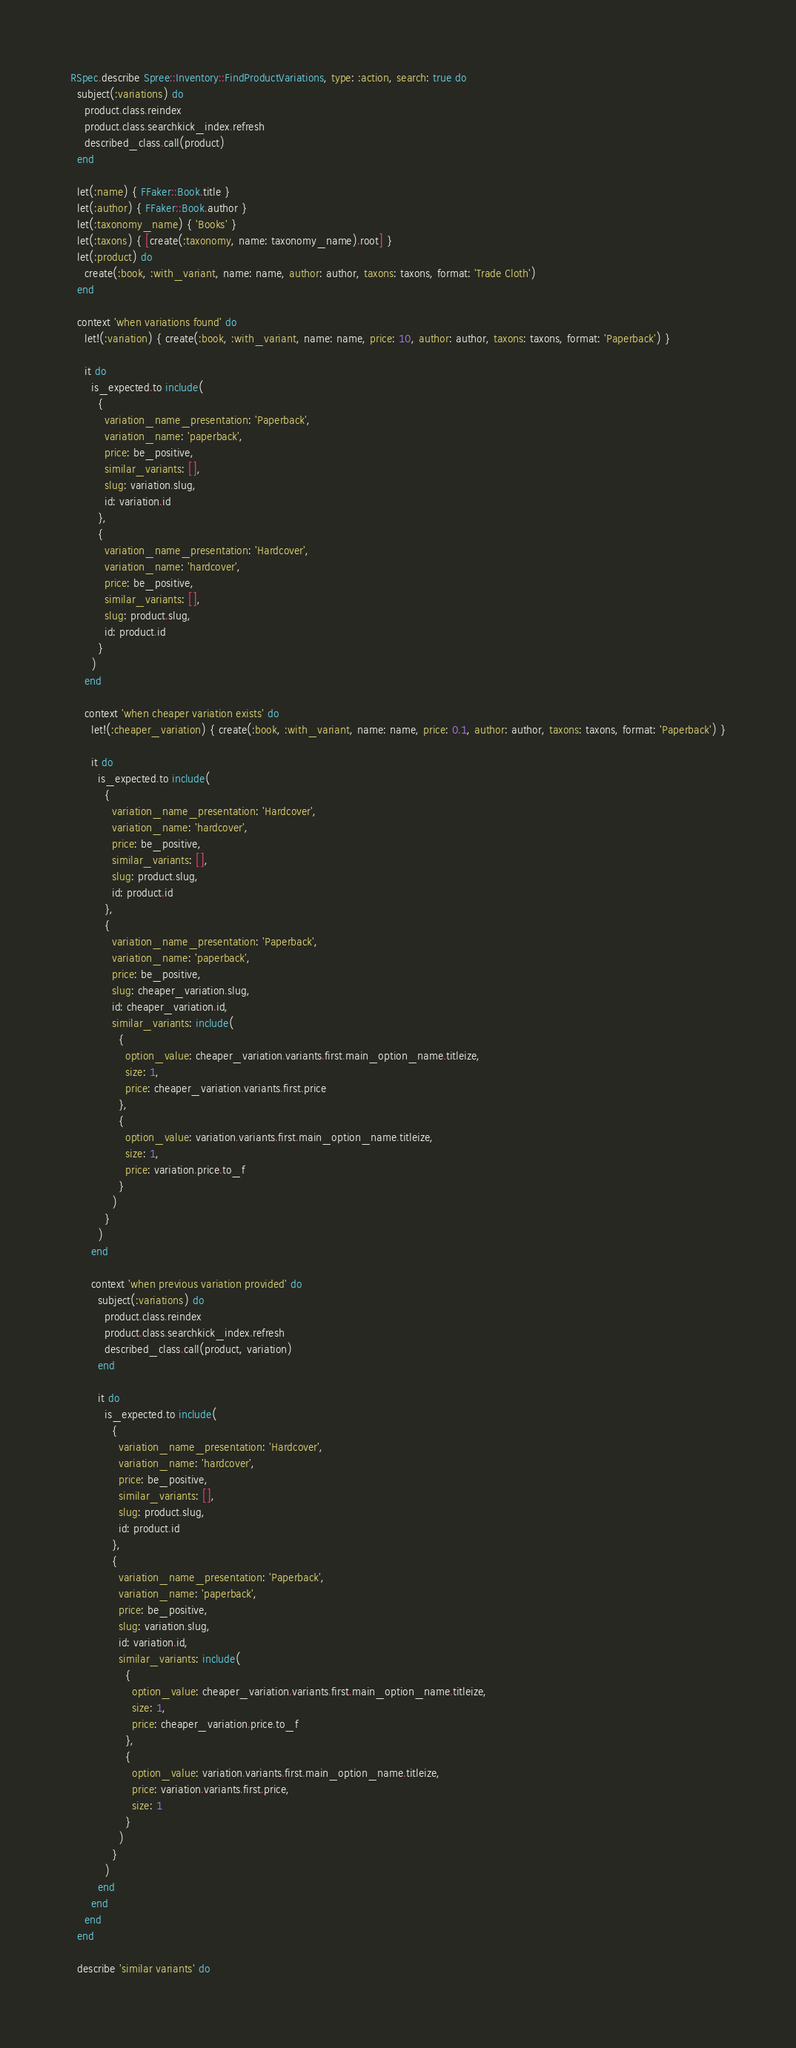Convert code to text. <code><loc_0><loc_0><loc_500><loc_500><_Ruby_>RSpec.describe Spree::Inventory::FindProductVariations, type: :action, search: true do
  subject(:variations) do
    product.class.reindex
    product.class.searchkick_index.refresh
    described_class.call(product)
  end

  let(:name) { FFaker::Book.title }
  let(:author) { FFaker::Book.author }
  let(:taxonomy_name) { 'Books' }
  let(:taxons) { [create(:taxonomy, name: taxonomy_name).root] }
  let(:product) do
    create(:book, :with_variant, name: name, author: author, taxons: taxons, format: 'Trade Cloth')
  end

  context 'when variations found' do
    let!(:variation) { create(:book, :with_variant, name: name, price: 10, author: author, taxons: taxons, format: 'Paperback') }

    it do
      is_expected.to include(
        {
          variation_name_presentation: 'Paperback',
          variation_name: 'paperback',
          price: be_positive,
          similar_variants: [],
          slug: variation.slug,
          id: variation.id
        },
        {
          variation_name_presentation: 'Hardcover',
          variation_name: 'hardcover',
          price: be_positive,
          similar_variants: [],
          slug: product.slug,
          id: product.id
        }
      )
    end

    context 'when cheaper variation exists' do
      let!(:cheaper_variation) { create(:book, :with_variant, name: name, price: 0.1, author: author, taxons: taxons, format: 'Paperback') }

      it do
        is_expected.to include(
          {
            variation_name_presentation: 'Hardcover',
            variation_name: 'hardcover',
            price: be_positive,
            similar_variants: [],
            slug: product.slug,
            id: product.id
          },
          {
            variation_name_presentation: 'Paperback',
            variation_name: 'paperback',
            price: be_positive,
            slug: cheaper_variation.slug,
            id: cheaper_variation.id,
            similar_variants: include(
              {
                option_value: cheaper_variation.variants.first.main_option_name.titleize,
                size: 1,
                price: cheaper_variation.variants.first.price
              },
              {
                option_value: variation.variants.first.main_option_name.titleize,
                size: 1,
                price: variation.price.to_f
              }
            )
          }
        )
      end

      context 'when previous variation provided' do
        subject(:variations) do
          product.class.reindex
          product.class.searchkick_index.refresh
          described_class.call(product, variation)
        end

        it do
          is_expected.to include(
            {
              variation_name_presentation: 'Hardcover',
              variation_name: 'hardcover',
              price: be_positive,
              similar_variants: [],
              slug: product.slug,
              id: product.id
            },
            {
              variation_name_presentation: 'Paperback',
              variation_name: 'paperback',
              price: be_positive,
              slug: variation.slug,
              id: variation.id,
              similar_variants: include(
                {
                  option_value: cheaper_variation.variants.first.main_option_name.titleize,
                  size: 1,
                  price: cheaper_variation.price.to_f
                },
                {
                  option_value: variation.variants.first.main_option_name.titleize,
                  price: variation.variants.first.price,
                  size: 1
                }
              )
            }
          )
        end
      end
    end
  end

  describe 'similar variants' do</code> 